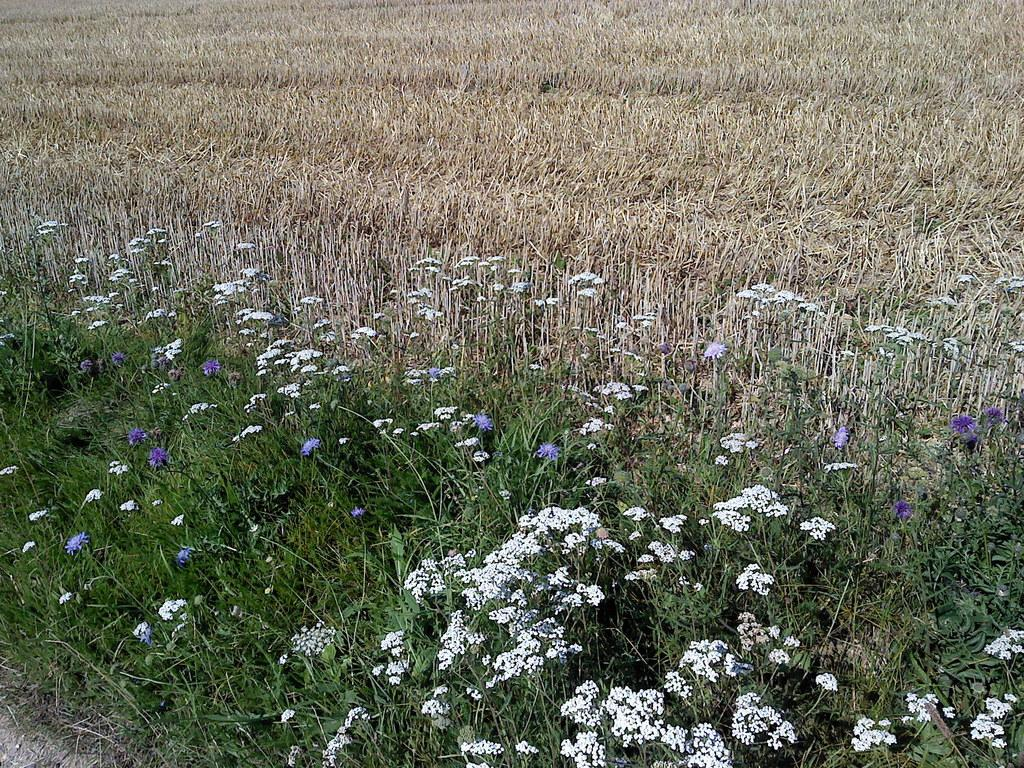What type of living organisms can be seen in the image? There are flowers and plants in the image. Can you describe the plants in the image? The plants in the image are not specified, but they are present alongside the flowers. What type of muscle can be seen in the image? There is no muscle present in the image; it features flowers and plants. Can you describe the curve of the cub in the image? There is no cub present in the image, and therefore no curve to describe. 